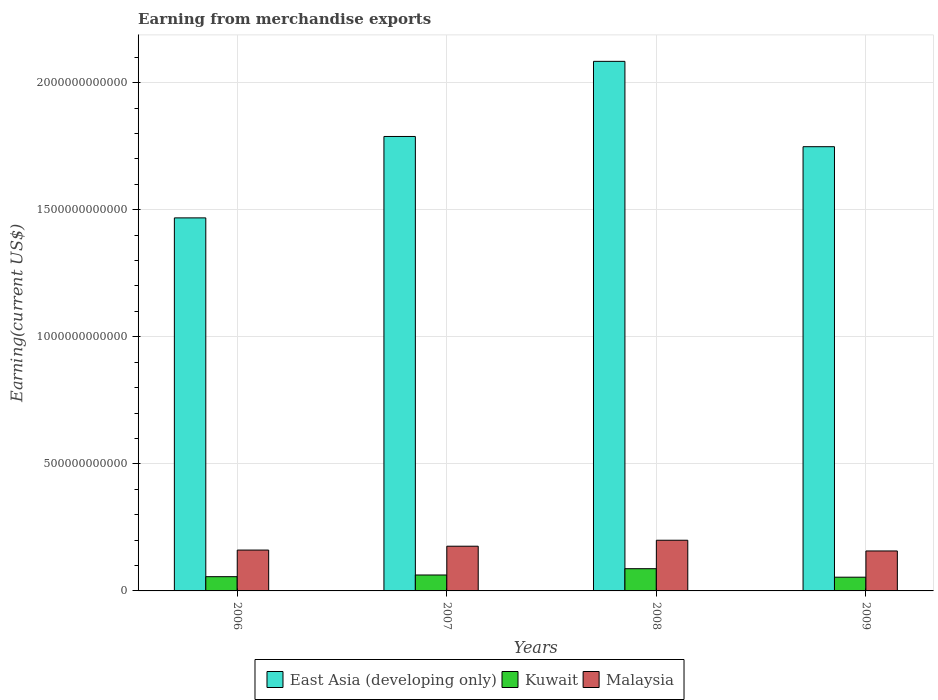How many different coloured bars are there?
Provide a short and direct response. 3. Are the number of bars on each tick of the X-axis equal?
Give a very brief answer. Yes. What is the amount earned from merchandise exports in Malaysia in 2009?
Provide a short and direct response. 1.57e+11. Across all years, what is the maximum amount earned from merchandise exports in Malaysia?
Provide a succinct answer. 1.99e+11. Across all years, what is the minimum amount earned from merchandise exports in Malaysia?
Provide a succinct answer. 1.57e+11. In which year was the amount earned from merchandise exports in Kuwait maximum?
Provide a succinct answer. 2008. What is the total amount earned from merchandise exports in Kuwait in the graph?
Your response must be concise. 2.60e+11. What is the difference between the amount earned from merchandise exports in Malaysia in 2006 and that in 2009?
Give a very brief answer. 3.50e+09. What is the difference between the amount earned from merchandise exports in Malaysia in 2007 and the amount earned from merchandise exports in East Asia (developing only) in 2009?
Ensure brevity in your answer.  -1.57e+12. What is the average amount earned from merchandise exports in Malaysia per year?
Your answer should be very brief. 1.73e+11. In the year 2008, what is the difference between the amount earned from merchandise exports in Malaysia and amount earned from merchandise exports in Kuwait?
Provide a succinct answer. 1.12e+11. What is the ratio of the amount earned from merchandise exports in Malaysia in 2006 to that in 2009?
Your response must be concise. 1.02. Is the difference between the amount earned from merchandise exports in Malaysia in 2006 and 2008 greater than the difference between the amount earned from merchandise exports in Kuwait in 2006 and 2008?
Your response must be concise. No. What is the difference between the highest and the second highest amount earned from merchandise exports in Kuwait?
Offer a very short reply. 2.48e+1. What is the difference between the highest and the lowest amount earned from merchandise exports in East Asia (developing only)?
Offer a very short reply. 6.16e+11. In how many years, is the amount earned from merchandise exports in Kuwait greater than the average amount earned from merchandise exports in Kuwait taken over all years?
Make the answer very short. 1. Is the sum of the amount earned from merchandise exports in East Asia (developing only) in 2007 and 2009 greater than the maximum amount earned from merchandise exports in Malaysia across all years?
Give a very brief answer. Yes. What does the 1st bar from the left in 2009 represents?
Ensure brevity in your answer.  East Asia (developing only). What does the 1st bar from the right in 2009 represents?
Offer a very short reply. Malaysia. What is the difference between two consecutive major ticks on the Y-axis?
Provide a short and direct response. 5.00e+11. Are the values on the major ticks of Y-axis written in scientific E-notation?
Give a very brief answer. No. Does the graph contain grids?
Your answer should be very brief. Yes. Where does the legend appear in the graph?
Give a very brief answer. Bottom center. How many legend labels are there?
Ensure brevity in your answer.  3. How are the legend labels stacked?
Offer a very short reply. Horizontal. What is the title of the graph?
Provide a short and direct response. Earning from merchandise exports. Does "Brazil" appear as one of the legend labels in the graph?
Ensure brevity in your answer.  No. What is the label or title of the X-axis?
Your answer should be compact. Years. What is the label or title of the Y-axis?
Make the answer very short. Earning(current US$). What is the Earning(current US$) in East Asia (developing only) in 2006?
Your response must be concise. 1.47e+12. What is the Earning(current US$) of Kuwait in 2006?
Ensure brevity in your answer.  5.60e+1. What is the Earning(current US$) of Malaysia in 2006?
Give a very brief answer. 1.61e+11. What is the Earning(current US$) in East Asia (developing only) in 2007?
Your answer should be very brief. 1.79e+12. What is the Earning(current US$) in Kuwait in 2007?
Ensure brevity in your answer.  6.27e+1. What is the Earning(current US$) in Malaysia in 2007?
Make the answer very short. 1.76e+11. What is the Earning(current US$) in East Asia (developing only) in 2008?
Offer a terse response. 2.08e+12. What is the Earning(current US$) in Kuwait in 2008?
Provide a succinct answer. 8.75e+1. What is the Earning(current US$) of Malaysia in 2008?
Offer a terse response. 1.99e+11. What is the Earning(current US$) in East Asia (developing only) in 2009?
Provide a succinct answer. 1.75e+12. What is the Earning(current US$) in Kuwait in 2009?
Your response must be concise. 5.40e+1. What is the Earning(current US$) of Malaysia in 2009?
Keep it short and to the point. 1.57e+11. Across all years, what is the maximum Earning(current US$) of East Asia (developing only)?
Provide a succinct answer. 2.08e+12. Across all years, what is the maximum Earning(current US$) in Kuwait?
Provide a succinct answer. 8.75e+1. Across all years, what is the maximum Earning(current US$) in Malaysia?
Keep it short and to the point. 1.99e+11. Across all years, what is the minimum Earning(current US$) in East Asia (developing only)?
Your response must be concise. 1.47e+12. Across all years, what is the minimum Earning(current US$) in Kuwait?
Offer a very short reply. 5.40e+1. Across all years, what is the minimum Earning(current US$) in Malaysia?
Offer a terse response. 1.57e+11. What is the total Earning(current US$) of East Asia (developing only) in the graph?
Your answer should be very brief. 7.09e+12. What is the total Earning(current US$) of Kuwait in the graph?
Provide a succinct answer. 2.60e+11. What is the total Earning(current US$) in Malaysia in the graph?
Give a very brief answer. 6.93e+11. What is the difference between the Earning(current US$) of East Asia (developing only) in 2006 and that in 2007?
Give a very brief answer. -3.20e+11. What is the difference between the Earning(current US$) of Kuwait in 2006 and that in 2007?
Offer a terse response. -6.68e+09. What is the difference between the Earning(current US$) in Malaysia in 2006 and that in 2007?
Provide a succinct answer. -1.52e+1. What is the difference between the Earning(current US$) in East Asia (developing only) in 2006 and that in 2008?
Give a very brief answer. -6.16e+11. What is the difference between the Earning(current US$) of Kuwait in 2006 and that in 2008?
Give a very brief answer. -3.14e+1. What is the difference between the Earning(current US$) of Malaysia in 2006 and that in 2008?
Your response must be concise. -3.87e+1. What is the difference between the Earning(current US$) of East Asia (developing only) in 2006 and that in 2009?
Provide a succinct answer. -2.80e+11. What is the difference between the Earning(current US$) of Kuwait in 2006 and that in 2009?
Your answer should be very brief. 2.01e+09. What is the difference between the Earning(current US$) of Malaysia in 2006 and that in 2009?
Your response must be concise. 3.50e+09. What is the difference between the Earning(current US$) in East Asia (developing only) in 2007 and that in 2008?
Your answer should be compact. -2.96e+11. What is the difference between the Earning(current US$) of Kuwait in 2007 and that in 2008?
Ensure brevity in your answer.  -2.48e+1. What is the difference between the Earning(current US$) of Malaysia in 2007 and that in 2008?
Give a very brief answer. -2.34e+1. What is the difference between the Earning(current US$) in East Asia (developing only) in 2007 and that in 2009?
Your answer should be very brief. 4.02e+1. What is the difference between the Earning(current US$) in Kuwait in 2007 and that in 2009?
Provide a succinct answer. 8.68e+09. What is the difference between the Earning(current US$) in Malaysia in 2007 and that in 2009?
Make the answer very short. 1.87e+1. What is the difference between the Earning(current US$) of East Asia (developing only) in 2008 and that in 2009?
Provide a short and direct response. 3.36e+11. What is the difference between the Earning(current US$) in Kuwait in 2008 and that in 2009?
Provide a short and direct response. 3.34e+1. What is the difference between the Earning(current US$) in Malaysia in 2008 and that in 2009?
Ensure brevity in your answer.  4.22e+1. What is the difference between the Earning(current US$) in East Asia (developing only) in 2006 and the Earning(current US$) in Kuwait in 2007?
Keep it short and to the point. 1.41e+12. What is the difference between the Earning(current US$) of East Asia (developing only) in 2006 and the Earning(current US$) of Malaysia in 2007?
Provide a short and direct response. 1.29e+12. What is the difference between the Earning(current US$) in Kuwait in 2006 and the Earning(current US$) in Malaysia in 2007?
Ensure brevity in your answer.  -1.20e+11. What is the difference between the Earning(current US$) in East Asia (developing only) in 2006 and the Earning(current US$) in Kuwait in 2008?
Your answer should be very brief. 1.38e+12. What is the difference between the Earning(current US$) in East Asia (developing only) in 2006 and the Earning(current US$) in Malaysia in 2008?
Your answer should be compact. 1.27e+12. What is the difference between the Earning(current US$) of Kuwait in 2006 and the Earning(current US$) of Malaysia in 2008?
Offer a very short reply. -1.43e+11. What is the difference between the Earning(current US$) in East Asia (developing only) in 2006 and the Earning(current US$) in Kuwait in 2009?
Your answer should be compact. 1.41e+12. What is the difference between the Earning(current US$) in East Asia (developing only) in 2006 and the Earning(current US$) in Malaysia in 2009?
Provide a short and direct response. 1.31e+12. What is the difference between the Earning(current US$) in Kuwait in 2006 and the Earning(current US$) in Malaysia in 2009?
Make the answer very short. -1.01e+11. What is the difference between the Earning(current US$) of East Asia (developing only) in 2007 and the Earning(current US$) of Kuwait in 2008?
Offer a terse response. 1.70e+12. What is the difference between the Earning(current US$) in East Asia (developing only) in 2007 and the Earning(current US$) in Malaysia in 2008?
Provide a succinct answer. 1.59e+12. What is the difference between the Earning(current US$) in Kuwait in 2007 and the Earning(current US$) in Malaysia in 2008?
Your response must be concise. -1.37e+11. What is the difference between the Earning(current US$) in East Asia (developing only) in 2007 and the Earning(current US$) in Kuwait in 2009?
Provide a short and direct response. 1.73e+12. What is the difference between the Earning(current US$) of East Asia (developing only) in 2007 and the Earning(current US$) of Malaysia in 2009?
Make the answer very short. 1.63e+12. What is the difference between the Earning(current US$) of Kuwait in 2007 and the Earning(current US$) of Malaysia in 2009?
Ensure brevity in your answer.  -9.46e+1. What is the difference between the Earning(current US$) of East Asia (developing only) in 2008 and the Earning(current US$) of Kuwait in 2009?
Offer a terse response. 2.03e+12. What is the difference between the Earning(current US$) in East Asia (developing only) in 2008 and the Earning(current US$) in Malaysia in 2009?
Provide a short and direct response. 1.93e+12. What is the difference between the Earning(current US$) of Kuwait in 2008 and the Earning(current US$) of Malaysia in 2009?
Provide a short and direct response. -6.98e+1. What is the average Earning(current US$) of East Asia (developing only) per year?
Make the answer very short. 1.77e+12. What is the average Earning(current US$) in Kuwait per year?
Your response must be concise. 6.50e+1. What is the average Earning(current US$) of Malaysia per year?
Offer a very short reply. 1.73e+11. In the year 2006, what is the difference between the Earning(current US$) in East Asia (developing only) and Earning(current US$) in Kuwait?
Your answer should be compact. 1.41e+12. In the year 2006, what is the difference between the Earning(current US$) in East Asia (developing only) and Earning(current US$) in Malaysia?
Keep it short and to the point. 1.31e+12. In the year 2006, what is the difference between the Earning(current US$) in Kuwait and Earning(current US$) in Malaysia?
Your answer should be compact. -1.05e+11. In the year 2007, what is the difference between the Earning(current US$) in East Asia (developing only) and Earning(current US$) in Kuwait?
Your answer should be very brief. 1.73e+12. In the year 2007, what is the difference between the Earning(current US$) in East Asia (developing only) and Earning(current US$) in Malaysia?
Your answer should be compact. 1.61e+12. In the year 2007, what is the difference between the Earning(current US$) in Kuwait and Earning(current US$) in Malaysia?
Keep it short and to the point. -1.13e+11. In the year 2008, what is the difference between the Earning(current US$) in East Asia (developing only) and Earning(current US$) in Kuwait?
Your answer should be compact. 2.00e+12. In the year 2008, what is the difference between the Earning(current US$) in East Asia (developing only) and Earning(current US$) in Malaysia?
Offer a very short reply. 1.88e+12. In the year 2008, what is the difference between the Earning(current US$) of Kuwait and Earning(current US$) of Malaysia?
Offer a very short reply. -1.12e+11. In the year 2009, what is the difference between the Earning(current US$) in East Asia (developing only) and Earning(current US$) in Kuwait?
Your answer should be compact. 1.69e+12. In the year 2009, what is the difference between the Earning(current US$) in East Asia (developing only) and Earning(current US$) in Malaysia?
Provide a short and direct response. 1.59e+12. In the year 2009, what is the difference between the Earning(current US$) of Kuwait and Earning(current US$) of Malaysia?
Offer a very short reply. -1.03e+11. What is the ratio of the Earning(current US$) of East Asia (developing only) in 2006 to that in 2007?
Offer a very short reply. 0.82. What is the ratio of the Earning(current US$) of Kuwait in 2006 to that in 2007?
Your answer should be very brief. 0.89. What is the ratio of the Earning(current US$) in Malaysia in 2006 to that in 2007?
Provide a short and direct response. 0.91. What is the ratio of the Earning(current US$) in East Asia (developing only) in 2006 to that in 2008?
Ensure brevity in your answer.  0.7. What is the ratio of the Earning(current US$) in Kuwait in 2006 to that in 2008?
Offer a terse response. 0.64. What is the ratio of the Earning(current US$) in Malaysia in 2006 to that in 2008?
Offer a very short reply. 0.81. What is the ratio of the Earning(current US$) of East Asia (developing only) in 2006 to that in 2009?
Provide a short and direct response. 0.84. What is the ratio of the Earning(current US$) in Kuwait in 2006 to that in 2009?
Provide a succinct answer. 1.04. What is the ratio of the Earning(current US$) in Malaysia in 2006 to that in 2009?
Ensure brevity in your answer.  1.02. What is the ratio of the Earning(current US$) in East Asia (developing only) in 2007 to that in 2008?
Offer a terse response. 0.86. What is the ratio of the Earning(current US$) in Kuwait in 2007 to that in 2008?
Provide a succinct answer. 0.72. What is the ratio of the Earning(current US$) of Malaysia in 2007 to that in 2008?
Your response must be concise. 0.88. What is the ratio of the Earning(current US$) in East Asia (developing only) in 2007 to that in 2009?
Ensure brevity in your answer.  1.02. What is the ratio of the Earning(current US$) in Kuwait in 2007 to that in 2009?
Provide a short and direct response. 1.16. What is the ratio of the Earning(current US$) of Malaysia in 2007 to that in 2009?
Your response must be concise. 1.12. What is the ratio of the Earning(current US$) in East Asia (developing only) in 2008 to that in 2009?
Your answer should be compact. 1.19. What is the ratio of the Earning(current US$) of Kuwait in 2008 to that in 2009?
Your response must be concise. 1.62. What is the ratio of the Earning(current US$) in Malaysia in 2008 to that in 2009?
Your response must be concise. 1.27. What is the difference between the highest and the second highest Earning(current US$) in East Asia (developing only)?
Keep it short and to the point. 2.96e+11. What is the difference between the highest and the second highest Earning(current US$) in Kuwait?
Offer a terse response. 2.48e+1. What is the difference between the highest and the second highest Earning(current US$) of Malaysia?
Your response must be concise. 2.34e+1. What is the difference between the highest and the lowest Earning(current US$) of East Asia (developing only)?
Give a very brief answer. 6.16e+11. What is the difference between the highest and the lowest Earning(current US$) of Kuwait?
Make the answer very short. 3.34e+1. What is the difference between the highest and the lowest Earning(current US$) of Malaysia?
Provide a succinct answer. 4.22e+1. 